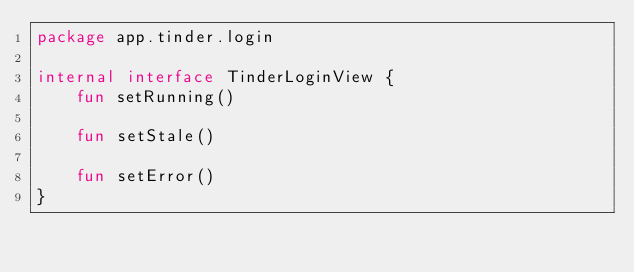Convert code to text. <code><loc_0><loc_0><loc_500><loc_500><_Kotlin_>package app.tinder.login

internal interface TinderLoginView {
    fun setRunning()

    fun setStale()

    fun setError()
}
</code> 